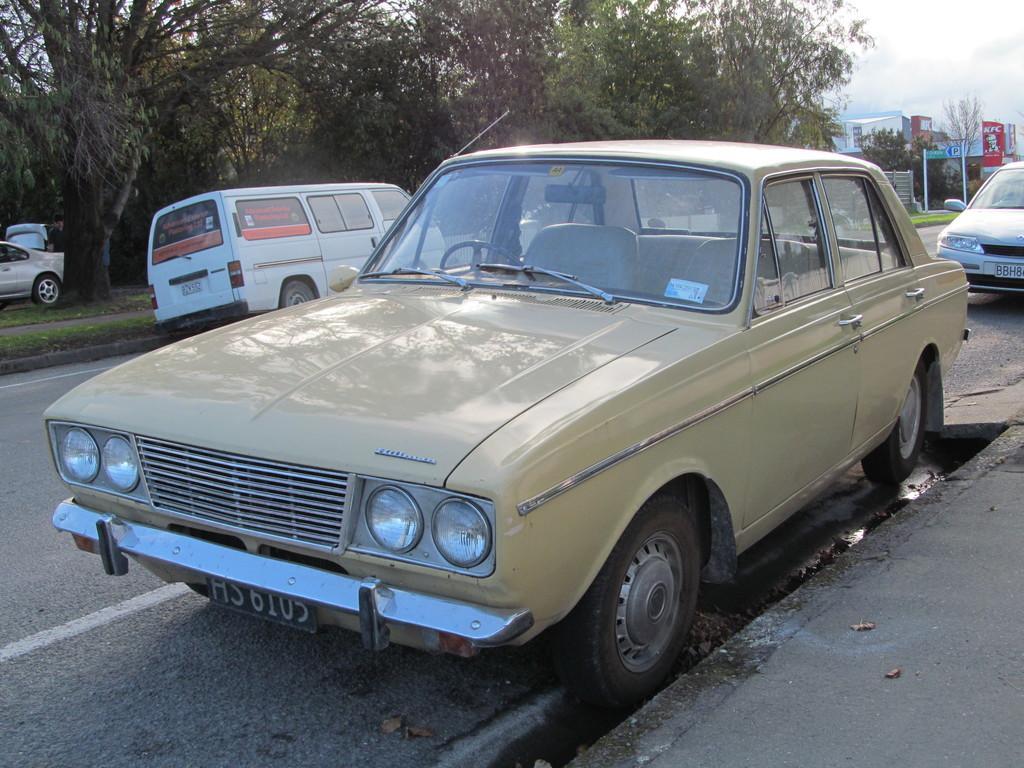Describe this image in one or two sentences. In this picture there are vehicles on the road. At the back there are buildings and trees and there are poles. At the top there is sky. At the bottom there is a road and there is grass. 